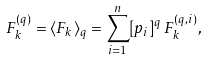Convert formula to latex. <formula><loc_0><loc_0><loc_500><loc_500>F ^ { ( q ) } _ { k } = \langle { F } _ { k } \rangle _ { q } = \sum _ { i = 1 } ^ { n } [ p _ { i } ] ^ { q } \, { F } ^ { ( q , i ) } _ { k } ,</formula> 